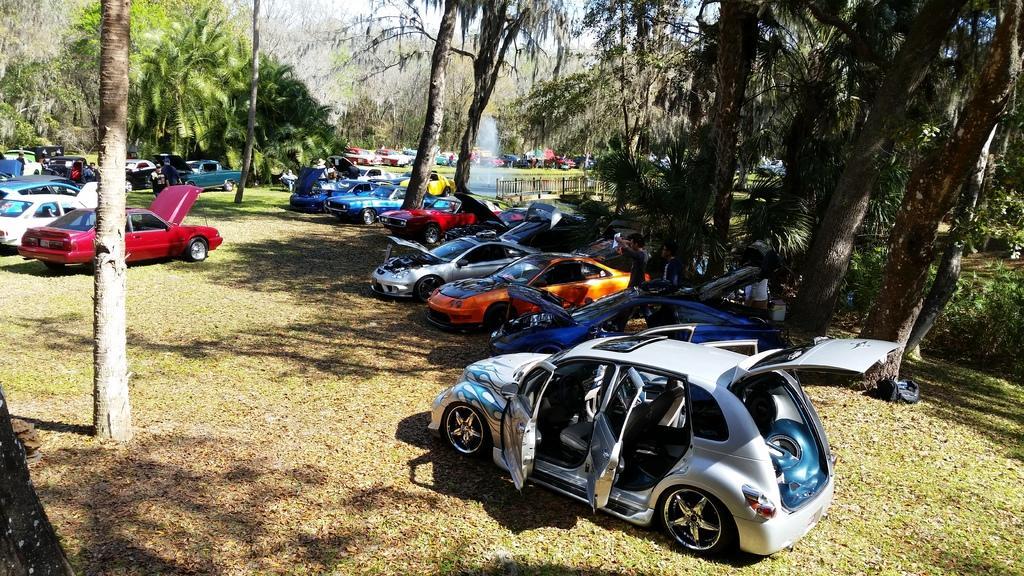Could you give a brief overview of what you see in this image? In this image we can see some cars with different colors are parked, there are some trees and in the background there is a sky. 